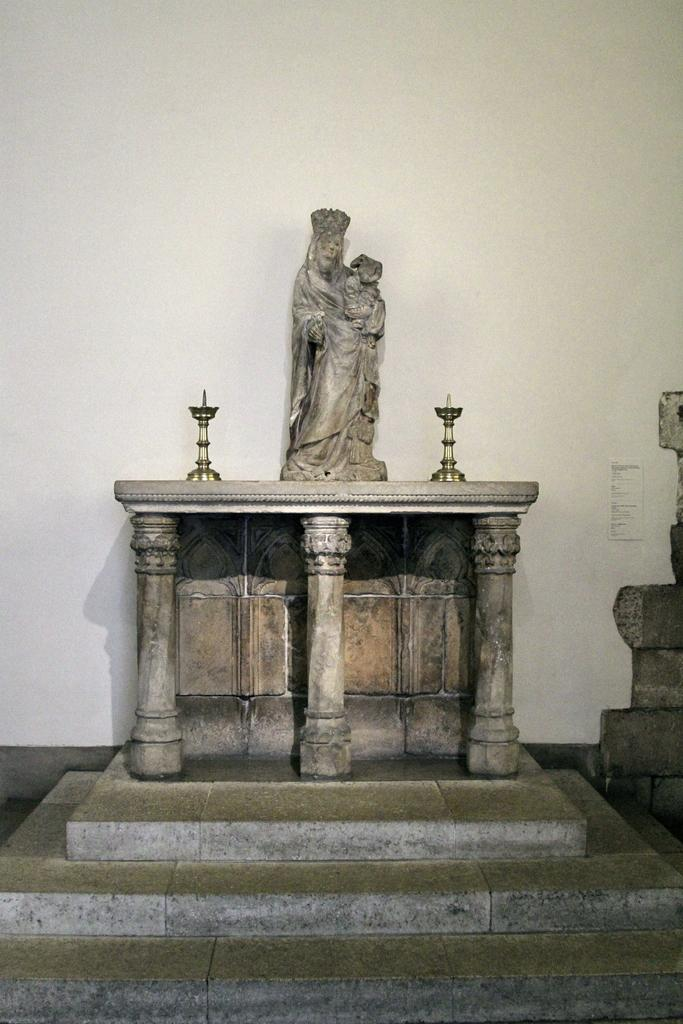What is the main subject in the image? There is a statue in the image. What other objects can be seen in the image? There are lamps, pillars, and steps visible in the image. What is visible in the background of the image? There is a wall visible in the background of the image. What type of oatmeal is being used to cover the statue in the image? There is no oatmeal present in the image, and the statue is not being covered by any substance. 